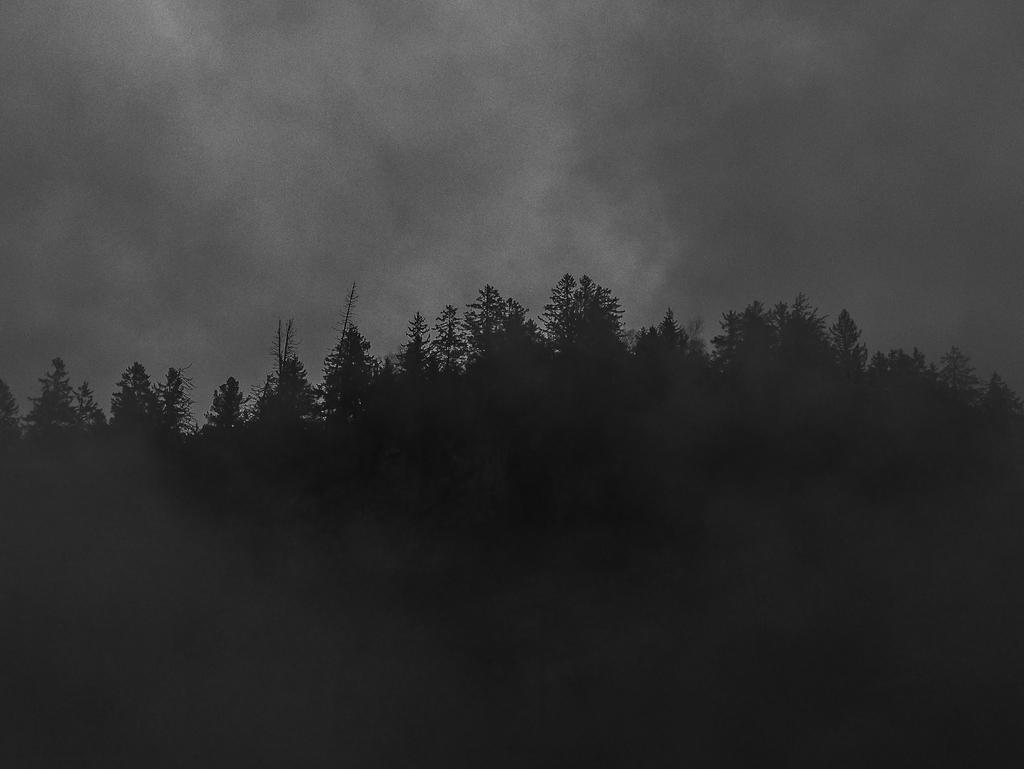In one or two sentences, can you explain what this image depicts? In this picture I can see trees and I can see sky and looks like picture is taken in the dark 